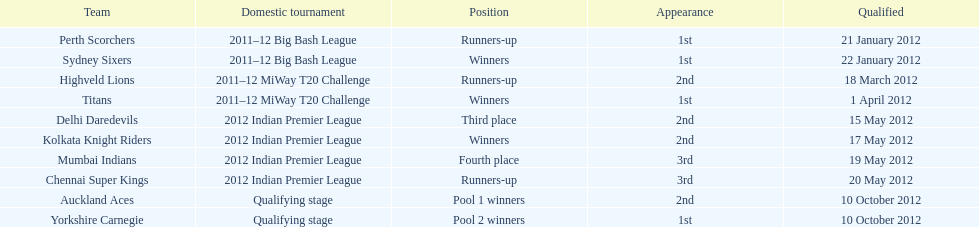Which team succeeded the titans in the miway t20 challenge? Highveld Lions. 